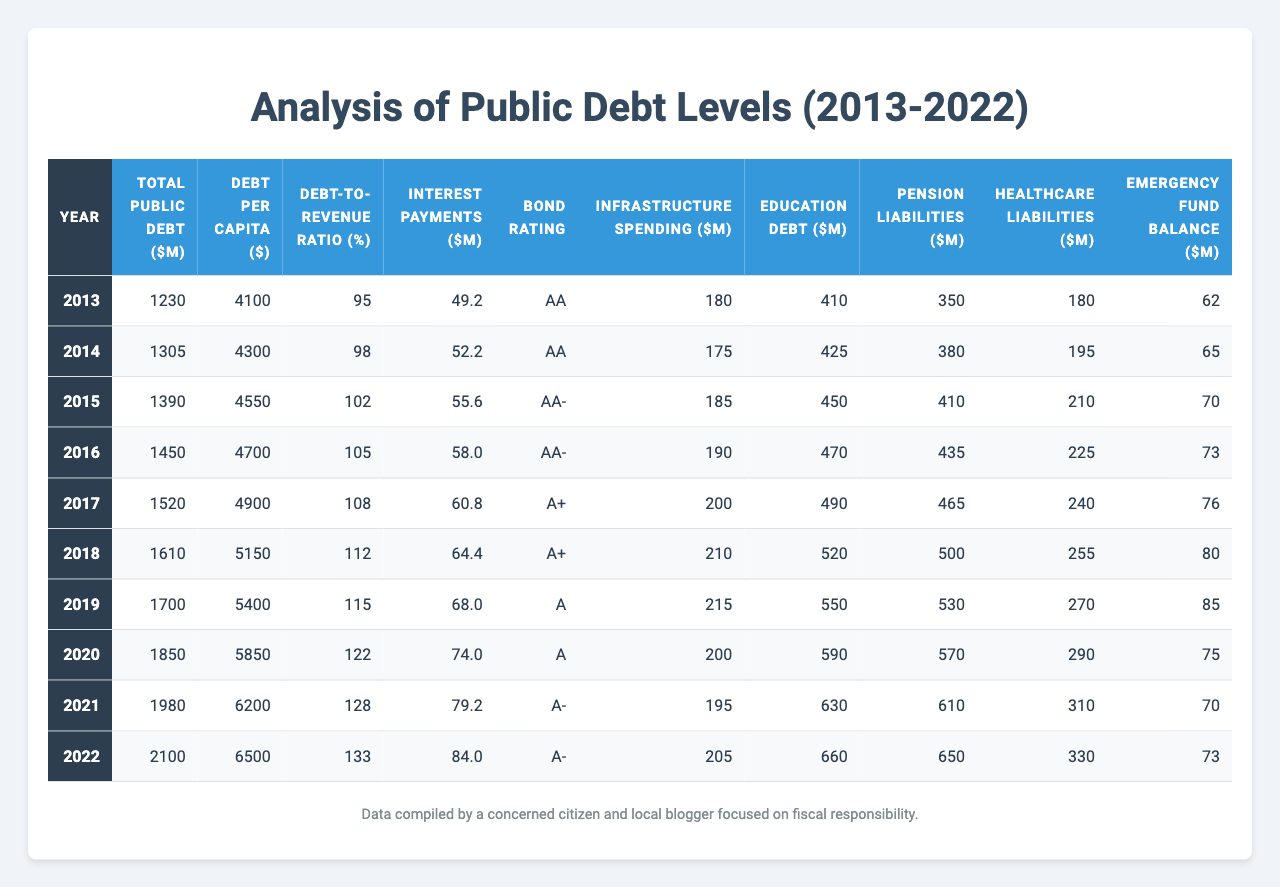What was the total public debt in 2022? The total public debt in 2022 is listed directly in the table, which shows the value as 2100 million dollars.
Answer: 2100 million dollars What was the debt per capita in 2015? The debt per capita for 2015 can be found in the table, where it shows the value as 4550 dollars.
Answer: 4550 dollars Has the emergency fund balance increased every year from 2013 to 2022? By checking the rows in the table, the emergency fund balance fluctuates, showing a peak in 2018, a decrease in 2020 and 2021, and returning to 73 million dollars in 2022. Therefore, it has not increased every year.
Answer: No What is the trend in total public debt from 2013 to 2022? Observing the total public debt column shows it increased each year from 1230 million in 2013 to 2100 million in 2022, demonstrating a consistent upward trend over the decade.
Answer: Upward trend What was the highest debt-to-revenue ratio recorded in the decade? The highest debt-to-revenue ratio in the table is 133%, recorded in 2022.
Answer: 133% What are the average interest payments over the decade? By adding the interest payments for each year (49.2 + 52.2 + 55.6 + 58.0 + 60.8 + 64.4 + 68.0 + 74.0 + 79.2 + 84.0) and dividing by 10, which gives a total of 600.4, the average is 600.4 / 10 = 60.04 million dollars.
Answer: 60.04 million dollars What percentage increase in debt per capita occurred from 2013 to 2022? The debt per capita was $4100 in 2013 and $6500 in 2022. The increase is $6500 - $4100 = $2400. To find the percentage increase, (2400 / 4100) * 100 = 58.54%, which rounds to approximately 58.54%.
Answer: 58.54% Was the bond rating ever lower than A- during the decade? The bond rating is listed in the table and shows the lowest rating was A, which occurred in 2019 and 2020. This confirms it was lower than A- in those years.
Answer: Yes In what year did education debt surpass $600 million? By checking the education debt column, it shows the education debt surpassed $600 million in 2021, where it was listed as 630 million dollars.
Answer: 2021 How much did pension liabilities increase from 2013 to 2022? The pension liabilities were 350 million dollars in 2013 and increased to 650 million dollars in 2022. The increase can be calculated as 650 - 350 = 300 million dollars.
Answer: 300 million dollars What is the relationship between total public debt and infrastructure spending in 2022? In 2022, total public debt is 2100 million dollars, and infrastructure spending is 205 million dollars. This shows that infrastructure spending is a small fraction of total public debt, indicating a potentially low allocation for infrastructure relative to overall debt.
Answer: Low allocation 